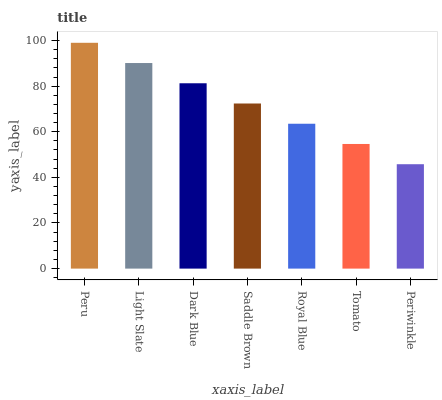Is Periwinkle the minimum?
Answer yes or no. Yes. Is Peru the maximum?
Answer yes or no. Yes. Is Light Slate the minimum?
Answer yes or no. No. Is Light Slate the maximum?
Answer yes or no. No. Is Peru greater than Light Slate?
Answer yes or no. Yes. Is Light Slate less than Peru?
Answer yes or no. Yes. Is Light Slate greater than Peru?
Answer yes or no. No. Is Peru less than Light Slate?
Answer yes or no. No. Is Saddle Brown the high median?
Answer yes or no. Yes. Is Saddle Brown the low median?
Answer yes or no. Yes. Is Tomato the high median?
Answer yes or no. No. Is Tomato the low median?
Answer yes or no. No. 